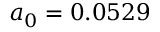<formula> <loc_0><loc_0><loc_500><loc_500>a _ { 0 } = 0 . 0 5 2 9</formula> 